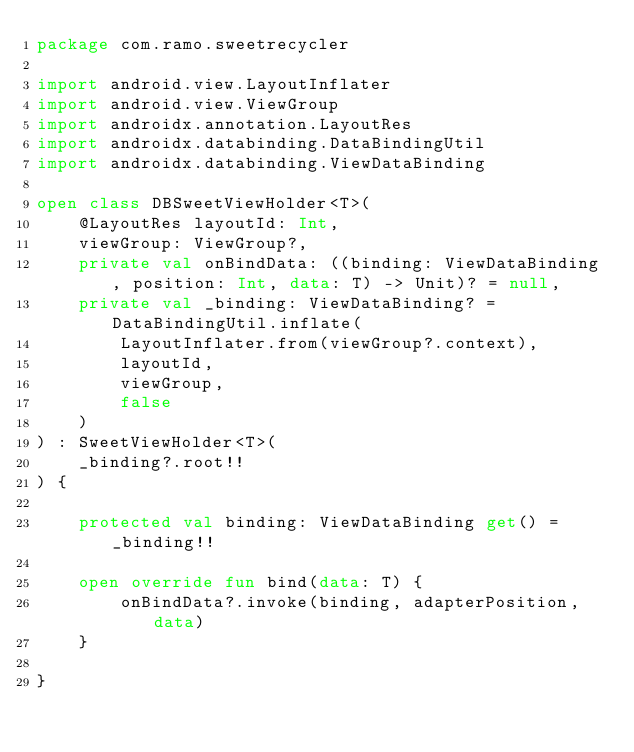<code> <loc_0><loc_0><loc_500><loc_500><_Kotlin_>package com.ramo.sweetrecycler

import android.view.LayoutInflater
import android.view.ViewGroup
import androidx.annotation.LayoutRes
import androidx.databinding.DataBindingUtil
import androidx.databinding.ViewDataBinding

open class DBSweetViewHolder<T>(
    @LayoutRes layoutId: Int,
    viewGroup: ViewGroup?,
    private val onBindData: ((binding: ViewDataBinding, position: Int, data: T) -> Unit)? = null,
    private val _binding: ViewDataBinding? = DataBindingUtil.inflate(
        LayoutInflater.from(viewGroup?.context),
        layoutId,
        viewGroup,
        false
    )
) : SweetViewHolder<T>(
    _binding?.root!!
) {

    protected val binding: ViewDataBinding get() = _binding!!

    open override fun bind(data: T) {
        onBindData?.invoke(binding, adapterPosition, data)
    }

}
</code> 